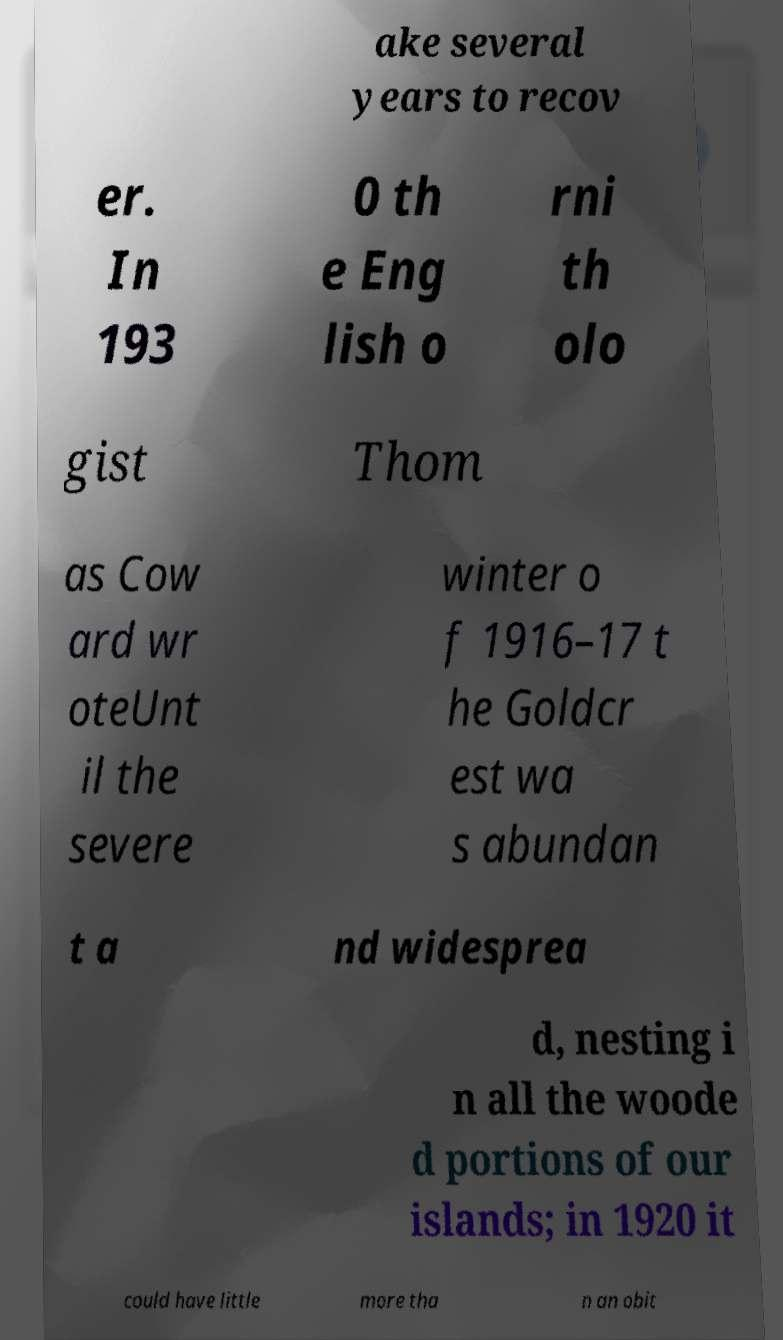I need the written content from this picture converted into text. Can you do that? ake several years to recov er. In 193 0 th e Eng lish o rni th olo gist Thom as Cow ard wr oteUnt il the severe winter o f 1916–17 t he Goldcr est wa s abundan t a nd widesprea d, nesting i n all the woode d portions of our islands; in 1920 it could have little more tha n an obit 